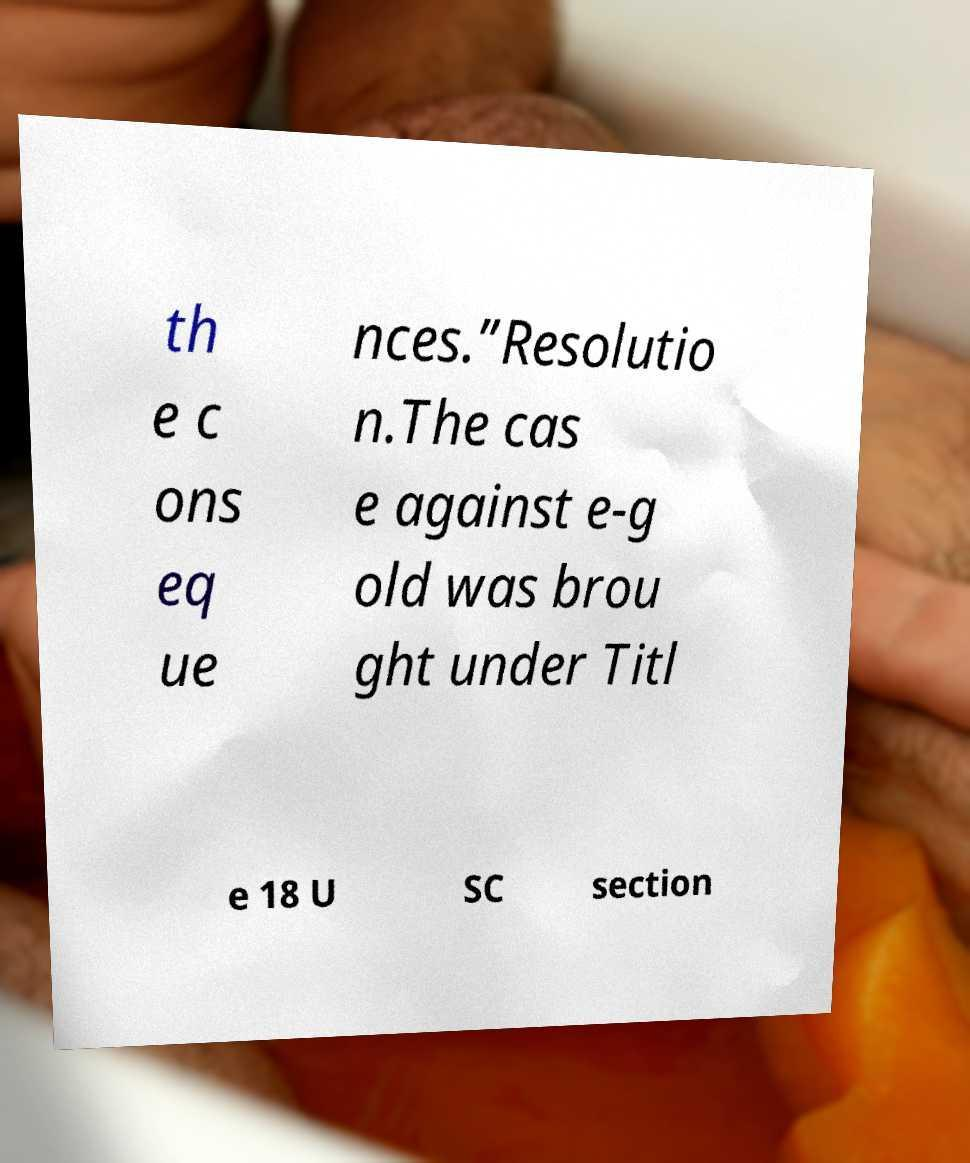I need the written content from this picture converted into text. Can you do that? th e c ons eq ue nces.”Resolutio n.The cas e against e-g old was brou ght under Titl e 18 U SC section 